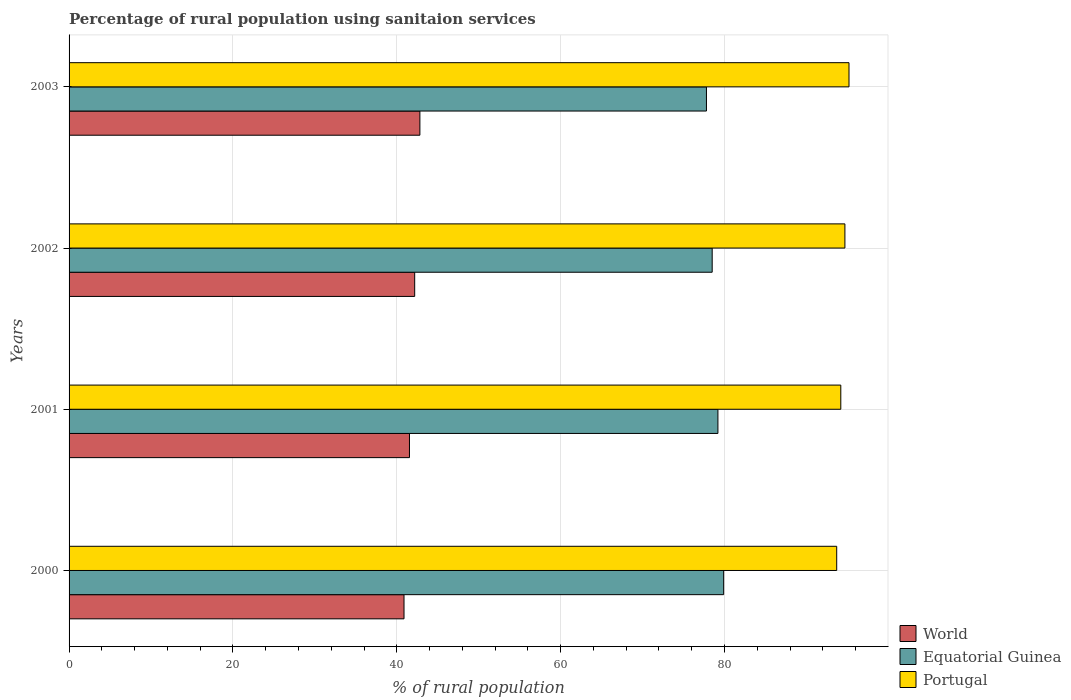Are the number of bars per tick equal to the number of legend labels?
Give a very brief answer. Yes. How many bars are there on the 2nd tick from the top?
Make the answer very short. 3. How many bars are there on the 3rd tick from the bottom?
Your answer should be compact. 3. What is the percentage of rural population using sanitaion services in World in 2000?
Make the answer very short. 40.88. Across all years, what is the maximum percentage of rural population using sanitaion services in Portugal?
Your answer should be compact. 95.2. Across all years, what is the minimum percentage of rural population using sanitaion services in World?
Make the answer very short. 40.88. What is the total percentage of rural population using sanitaion services in World in the graph?
Give a very brief answer. 167.44. What is the difference between the percentage of rural population using sanitaion services in World in 2000 and that in 2001?
Ensure brevity in your answer.  -0.67. What is the difference between the percentage of rural population using sanitaion services in Portugal in 2001 and the percentage of rural population using sanitaion services in World in 2003?
Your answer should be very brief. 51.38. What is the average percentage of rural population using sanitaion services in Equatorial Guinea per year?
Keep it short and to the point. 78.85. In the year 2002, what is the difference between the percentage of rural population using sanitaion services in World and percentage of rural population using sanitaion services in Portugal?
Ensure brevity in your answer.  -52.51. In how many years, is the percentage of rural population using sanitaion services in Equatorial Guinea greater than 36 %?
Provide a succinct answer. 4. What is the ratio of the percentage of rural population using sanitaion services in Portugal in 2001 to that in 2002?
Offer a very short reply. 0.99. Is the difference between the percentage of rural population using sanitaion services in World in 2000 and 2003 greater than the difference between the percentage of rural population using sanitaion services in Portugal in 2000 and 2003?
Keep it short and to the point. No. What is the difference between the highest and the second highest percentage of rural population using sanitaion services in Equatorial Guinea?
Your answer should be very brief. 0.7. What is the difference between the highest and the lowest percentage of rural population using sanitaion services in Portugal?
Provide a short and direct response. 1.5. Is the sum of the percentage of rural population using sanitaion services in Portugal in 2001 and 2003 greater than the maximum percentage of rural population using sanitaion services in Equatorial Guinea across all years?
Ensure brevity in your answer.  Yes. What does the 1st bar from the top in 2002 represents?
Provide a short and direct response. Portugal. What does the 3rd bar from the bottom in 2003 represents?
Give a very brief answer. Portugal. How many years are there in the graph?
Your response must be concise. 4. Does the graph contain grids?
Your answer should be very brief. Yes. How many legend labels are there?
Your response must be concise. 3. How are the legend labels stacked?
Ensure brevity in your answer.  Vertical. What is the title of the graph?
Your response must be concise. Percentage of rural population using sanitaion services. What is the label or title of the X-axis?
Offer a very short reply. % of rural population. What is the label or title of the Y-axis?
Offer a terse response. Years. What is the % of rural population of World in 2000?
Offer a terse response. 40.88. What is the % of rural population of Equatorial Guinea in 2000?
Give a very brief answer. 79.9. What is the % of rural population of Portugal in 2000?
Ensure brevity in your answer.  93.7. What is the % of rural population of World in 2001?
Keep it short and to the point. 41.55. What is the % of rural population of Equatorial Guinea in 2001?
Ensure brevity in your answer.  79.2. What is the % of rural population in Portugal in 2001?
Your answer should be very brief. 94.2. What is the % of rural population in World in 2002?
Keep it short and to the point. 42.19. What is the % of rural population in Equatorial Guinea in 2002?
Offer a terse response. 78.5. What is the % of rural population of Portugal in 2002?
Make the answer very short. 94.7. What is the % of rural population in World in 2003?
Provide a succinct answer. 42.82. What is the % of rural population in Equatorial Guinea in 2003?
Your answer should be very brief. 77.8. What is the % of rural population of Portugal in 2003?
Give a very brief answer. 95.2. Across all years, what is the maximum % of rural population of World?
Your answer should be very brief. 42.82. Across all years, what is the maximum % of rural population in Equatorial Guinea?
Your answer should be compact. 79.9. Across all years, what is the maximum % of rural population of Portugal?
Offer a terse response. 95.2. Across all years, what is the minimum % of rural population in World?
Provide a succinct answer. 40.88. Across all years, what is the minimum % of rural population in Equatorial Guinea?
Provide a short and direct response. 77.8. Across all years, what is the minimum % of rural population of Portugal?
Your answer should be compact. 93.7. What is the total % of rural population of World in the graph?
Offer a very short reply. 167.44. What is the total % of rural population of Equatorial Guinea in the graph?
Offer a terse response. 315.4. What is the total % of rural population in Portugal in the graph?
Give a very brief answer. 377.8. What is the difference between the % of rural population of World in 2000 and that in 2001?
Your response must be concise. -0.67. What is the difference between the % of rural population of Portugal in 2000 and that in 2001?
Provide a short and direct response. -0.5. What is the difference between the % of rural population in World in 2000 and that in 2002?
Your answer should be compact. -1.3. What is the difference between the % of rural population of World in 2000 and that in 2003?
Make the answer very short. -1.94. What is the difference between the % of rural population of World in 2001 and that in 2002?
Ensure brevity in your answer.  -0.64. What is the difference between the % of rural population in World in 2001 and that in 2003?
Provide a short and direct response. -1.27. What is the difference between the % of rural population of Portugal in 2001 and that in 2003?
Give a very brief answer. -1. What is the difference between the % of rural population of World in 2002 and that in 2003?
Your answer should be compact. -0.64. What is the difference between the % of rural population in Equatorial Guinea in 2002 and that in 2003?
Offer a terse response. 0.7. What is the difference between the % of rural population in World in 2000 and the % of rural population in Equatorial Guinea in 2001?
Provide a short and direct response. -38.32. What is the difference between the % of rural population in World in 2000 and the % of rural population in Portugal in 2001?
Provide a short and direct response. -53.32. What is the difference between the % of rural population of Equatorial Guinea in 2000 and the % of rural population of Portugal in 2001?
Your response must be concise. -14.3. What is the difference between the % of rural population in World in 2000 and the % of rural population in Equatorial Guinea in 2002?
Your answer should be compact. -37.62. What is the difference between the % of rural population in World in 2000 and the % of rural population in Portugal in 2002?
Make the answer very short. -53.82. What is the difference between the % of rural population in Equatorial Guinea in 2000 and the % of rural population in Portugal in 2002?
Keep it short and to the point. -14.8. What is the difference between the % of rural population in World in 2000 and the % of rural population in Equatorial Guinea in 2003?
Offer a terse response. -36.92. What is the difference between the % of rural population of World in 2000 and the % of rural population of Portugal in 2003?
Your response must be concise. -54.32. What is the difference between the % of rural population in Equatorial Guinea in 2000 and the % of rural population in Portugal in 2003?
Your answer should be very brief. -15.3. What is the difference between the % of rural population of World in 2001 and the % of rural population of Equatorial Guinea in 2002?
Provide a short and direct response. -36.95. What is the difference between the % of rural population in World in 2001 and the % of rural population in Portugal in 2002?
Your response must be concise. -53.15. What is the difference between the % of rural population of Equatorial Guinea in 2001 and the % of rural population of Portugal in 2002?
Give a very brief answer. -15.5. What is the difference between the % of rural population of World in 2001 and the % of rural population of Equatorial Guinea in 2003?
Your answer should be very brief. -36.25. What is the difference between the % of rural population of World in 2001 and the % of rural population of Portugal in 2003?
Keep it short and to the point. -53.65. What is the difference between the % of rural population in Equatorial Guinea in 2001 and the % of rural population in Portugal in 2003?
Offer a terse response. -16. What is the difference between the % of rural population of World in 2002 and the % of rural population of Equatorial Guinea in 2003?
Provide a succinct answer. -35.61. What is the difference between the % of rural population of World in 2002 and the % of rural population of Portugal in 2003?
Provide a succinct answer. -53.01. What is the difference between the % of rural population in Equatorial Guinea in 2002 and the % of rural population in Portugal in 2003?
Provide a succinct answer. -16.7. What is the average % of rural population in World per year?
Provide a short and direct response. 41.86. What is the average % of rural population of Equatorial Guinea per year?
Keep it short and to the point. 78.85. What is the average % of rural population of Portugal per year?
Provide a short and direct response. 94.45. In the year 2000, what is the difference between the % of rural population of World and % of rural population of Equatorial Guinea?
Your answer should be very brief. -39.02. In the year 2000, what is the difference between the % of rural population in World and % of rural population in Portugal?
Your answer should be very brief. -52.82. In the year 2000, what is the difference between the % of rural population of Equatorial Guinea and % of rural population of Portugal?
Make the answer very short. -13.8. In the year 2001, what is the difference between the % of rural population of World and % of rural population of Equatorial Guinea?
Provide a succinct answer. -37.65. In the year 2001, what is the difference between the % of rural population of World and % of rural population of Portugal?
Your response must be concise. -52.65. In the year 2002, what is the difference between the % of rural population in World and % of rural population in Equatorial Guinea?
Offer a terse response. -36.31. In the year 2002, what is the difference between the % of rural population of World and % of rural population of Portugal?
Offer a terse response. -52.51. In the year 2002, what is the difference between the % of rural population of Equatorial Guinea and % of rural population of Portugal?
Make the answer very short. -16.2. In the year 2003, what is the difference between the % of rural population in World and % of rural population in Equatorial Guinea?
Your response must be concise. -34.98. In the year 2003, what is the difference between the % of rural population of World and % of rural population of Portugal?
Provide a succinct answer. -52.38. In the year 2003, what is the difference between the % of rural population of Equatorial Guinea and % of rural population of Portugal?
Provide a succinct answer. -17.4. What is the ratio of the % of rural population of World in 2000 to that in 2001?
Your answer should be compact. 0.98. What is the ratio of the % of rural population of Equatorial Guinea in 2000 to that in 2001?
Offer a very short reply. 1.01. What is the ratio of the % of rural population in Portugal in 2000 to that in 2001?
Provide a succinct answer. 0.99. What is the ratio of the % of rural population of World in 2000 to that in 2002?
Ensure brevity in your answer.  0.97. What is the ratio of the % of rural population in Equatorial Guinea in 2000 to that in 2002?
Offer a terse response. 1.02. What is the ratio of the % of rural population of Portugal in 2000 to that in 2002?
Provide a succinct answer. 0.99. What is the ratio of the % of rural population in World in 2000 to that in 2003?
Keep it short and to the point. 0.95. What is the ratio of the % of rural population of Portugal in 2000 to that in 2003?
Offer a very short reply. 0.98. What is the ratio of the % of rural population of World in 2001 to that in 2002?
Keep it short and to the point. 0.98. What is the ratio of the % of rural population in Equatorial Guinea in 2001 to that in 2002?
Provide a succinct answer. 1.01. What is the ratio of the % of rural population of Portugal in 2001 to that in 2002?
Make the answer very short. 0.99. What is the ratio of the % of rural population in World in 2001 to that in 2003?
Your response must be concise. 0.97. What is the ratio of the % of rural population of World in 2002 to that in 2003?
Give a very brief answer. 0.99. What is the ratio of the % of rural population of Equatorial Guinea in 2002 to that in 2003?
Offer a terse response. 1.01. What is the ratio of the % of rural population of Portugal in 2002 to that in 2003?
Make the answer very short. 0.99. What is the difference between the highest and the second highest % of rural population of World?
Give a very brief answer. 0.64. What is the difference between the highest and the second highest % of rural population of Portugal?
Offer a very short reply. 0.5. What is the difference between the highest and the lowest % of rural population of World?
Your answer should be compact. 1.94. What is the difference between the highest and the lowest % of rural population of Portugal?
Provide a succinct answer. 1.5. 